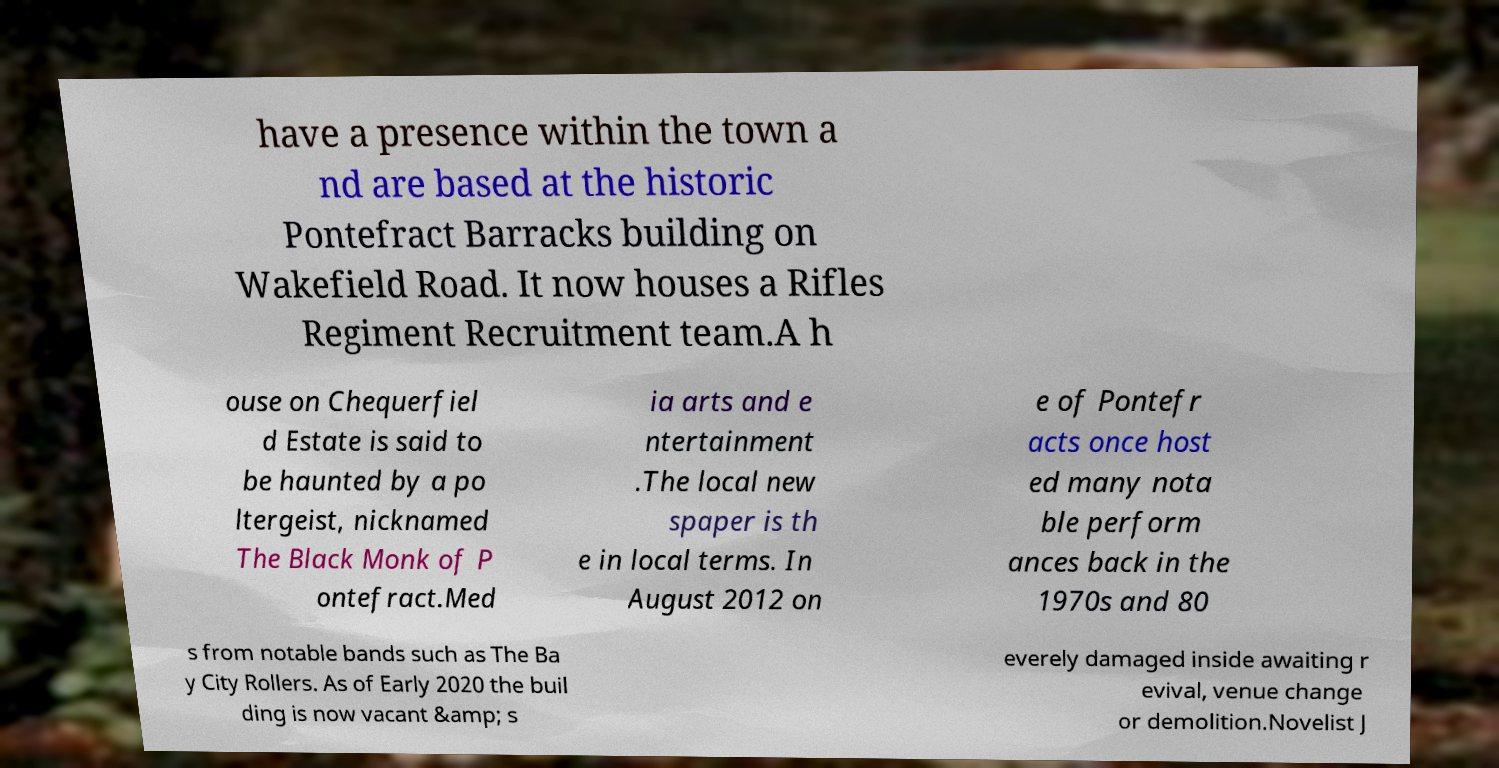Can you read and provide the text displayed in the image?This photo seems to have some interesting text. Can you extract and type it out for me? have a presence within the town a nd are based at the historic Pontefract Barracks building on Wakefield Road. It now houses a Rifles Regiment Recruitment team.A h ouse on Chequerfiel d Estate is said to be haunted by a po ltergeist, nicknamed The Black Monk of P ontefract.Med ia arts and e ntertainment .The local new spaper is th e in local terms. In August 2012 on e of Pontefr acts once host ed many nota ble perform ances back in the 1970s and 80 s from notable bands such as The Ba y City Rollers. As of Early 2020 the buil ding is now vacant &amp; s everely damaged inside awaiting r evival, venue change or demolition.Novelist J 